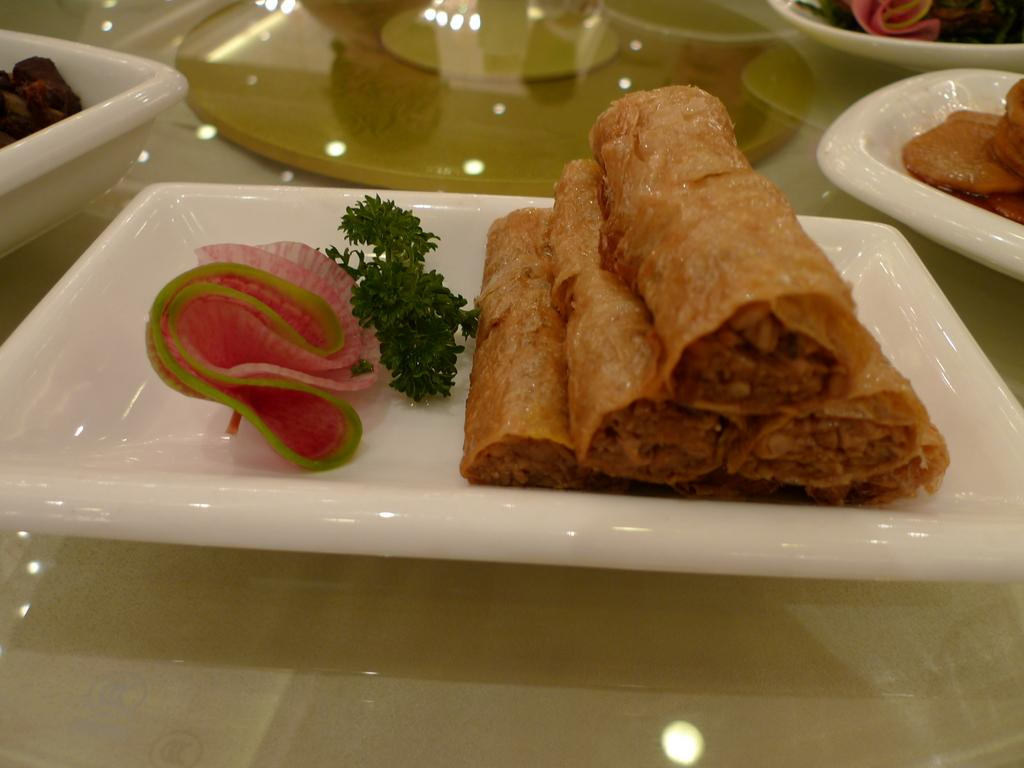What type of food items can be seen in the image? There are food items in bowls and trays in the image. Where are the bowls and trays placed? The bowls and trays are placed on a glass surface. What can be observed on the glass surface? Light reflections are visible on the glass surface. What sense is being stimulated by the food items in the image? The image does not convey any information about the senses being stimulated by the food items. 